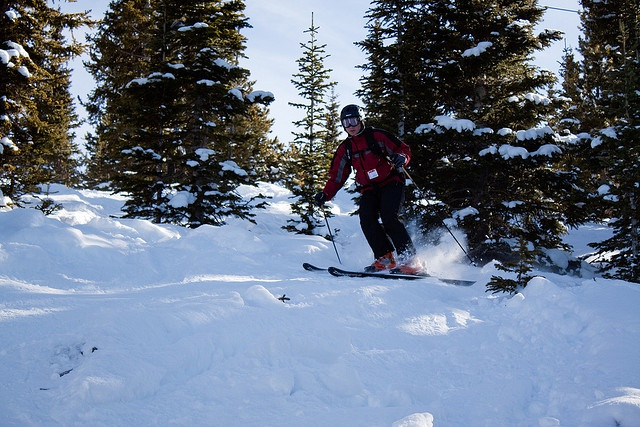Describe the objects in this image and their specific colors. I can see people in black, maroon, gray, and navy tones and skis in black, gray, navy, and blue tones in this image. 